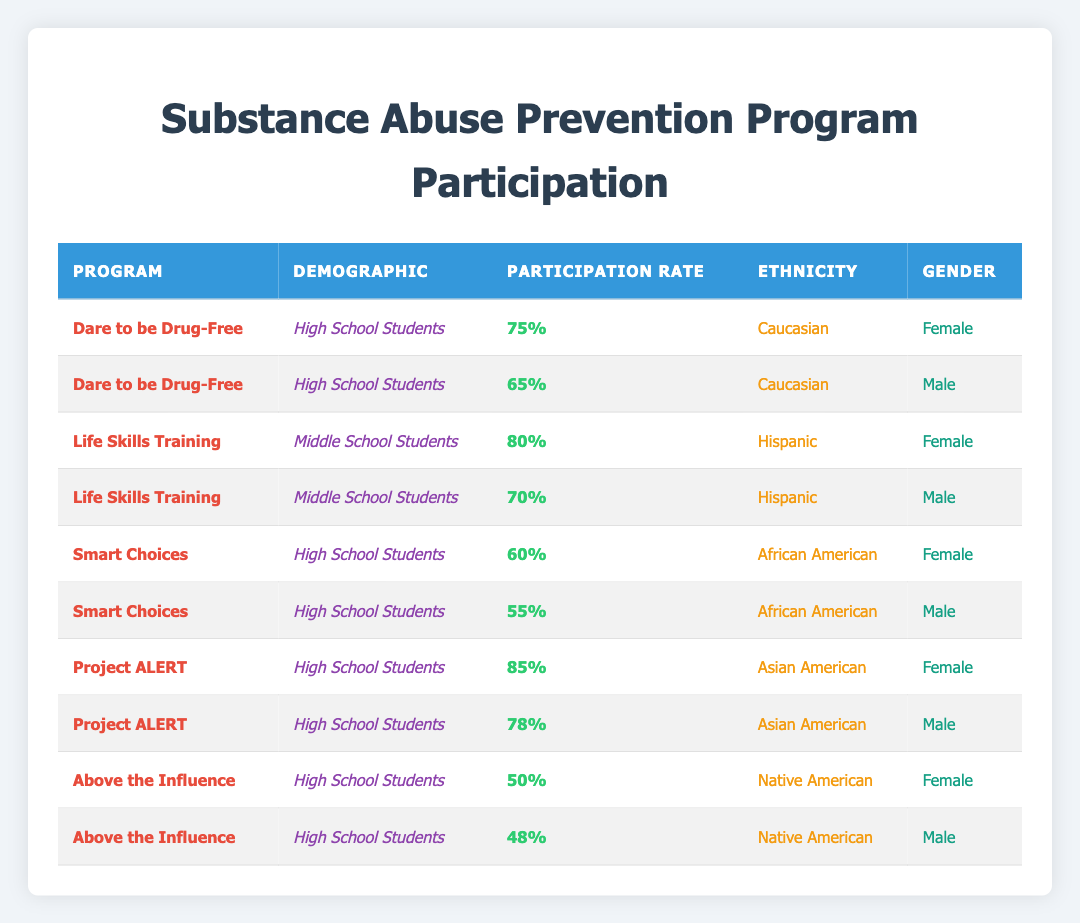What is the participation rate for Caucasian female high school students in the "Dare to be Drug-Free" program? According to the table, the participation rate for Caucasian female high school students in the "Dare to be Drug-Free" program is directly shown as 75%.
Answer: 75% What is the participation rate for Hispanic male middle school students in the "Life Skills Training" program? The table indicates that the participation rate for Hispanic male middle school students in the "Life Skills Training" program is 70%.
Answer: 70% Is the participation rate for male African American high school students higher than that for male Caucasian high school students? The participation rate for male African American high school students is 55%, while for male Caucasian students, it is 65%. Therefore, 55% is not higher than 65%.
Answer: No Which program has the highest participation rate among Asian American high school students? The participation rates for Asian American high school students are 85% in "Project ALERT" for females and 78% for males. The highest rate is 85% in "Project ALERT."
Answer: Project ALERT What is the average participation rate for high school students in the "Smart Choices" program? The participation rates for high school students in "Smart Choices" are 60% for females and 55% for males. To find the average, we sum them (60% + 55% = 115%) and divide by 2, which gives 115% / 2 = 57.5%.
Answer: 57.5% What is the total participation rate for middle school Hispanic students across both programs? The participation rates for middle school Hispanic students in "Life Skills Training" are 80% for females and 70% for males. The total is 80% + 70% = 150%.
Answer: 150% Are there any programs with a participation rate of less than 50% among high school students? The table shows that the lowest participation rate among high school students is 48% in the "Above the Influence" program for Native American males, which is less than 50%.
Answer: Yes What is the difference in participation rates between the highest and lowest programs for Native American high school students? The highest participation rate for Native American high school students is 50% in "Above the Influence" for females, and the lowest is 48% for males in the same program. The difference is 50% - 48% = 2%.
Answer: 2% 